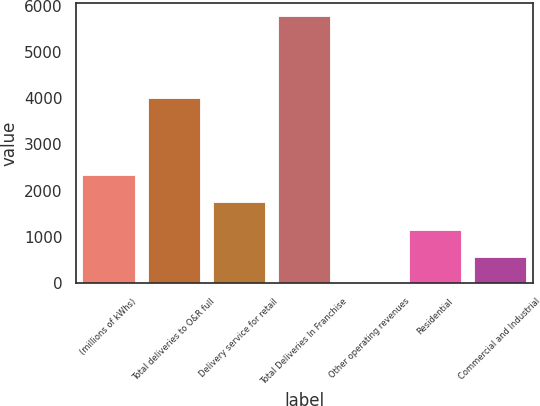Convert chart to OTSL. <chart><loc_0><loc_0><loc_500><loc_500><bar_chart><fcel>(millions of kWhs)<fcel>Total deliveries to O&R full<fcel>Delivery service for retail<fcel>Total Deliveries In Franchise<fcel>Other operating revenues<fcel>Residential<fcel>Commercial and Industrial<nl><fcel>2343.3<fcel>4010<fcel>1766<fcel>5776<fcel>3<fcel>1157.6<fcel>580.3<nl></chart> 